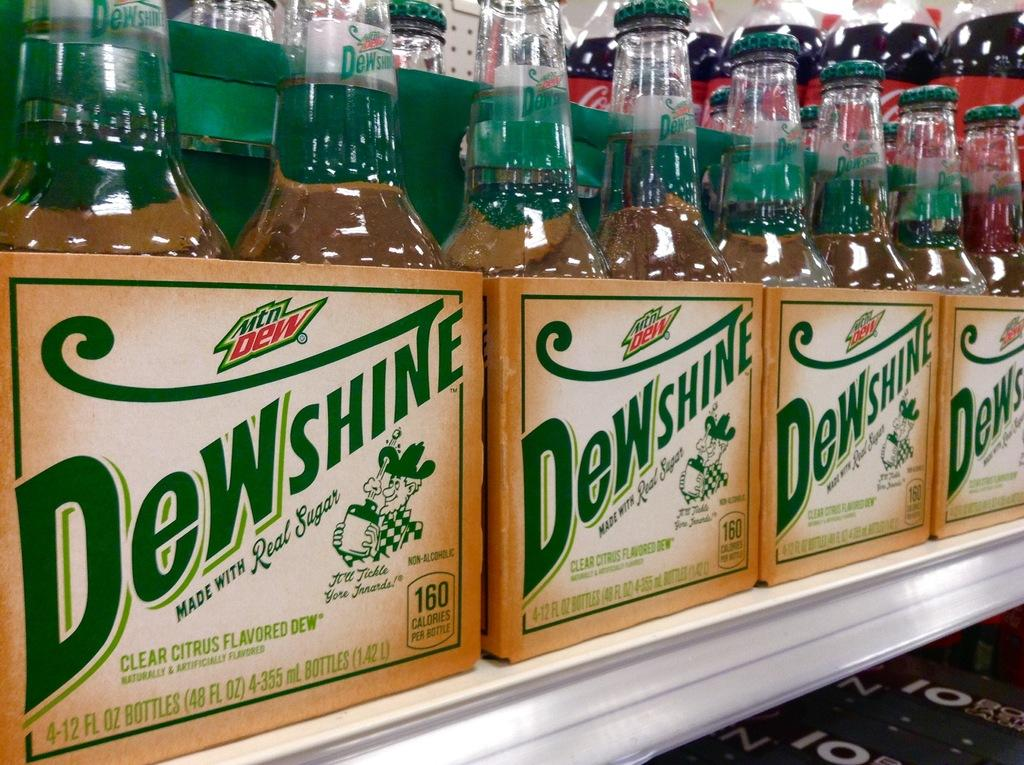<image>
Describe the image concisely. Six packs of Dewshine sitting on a shelf 